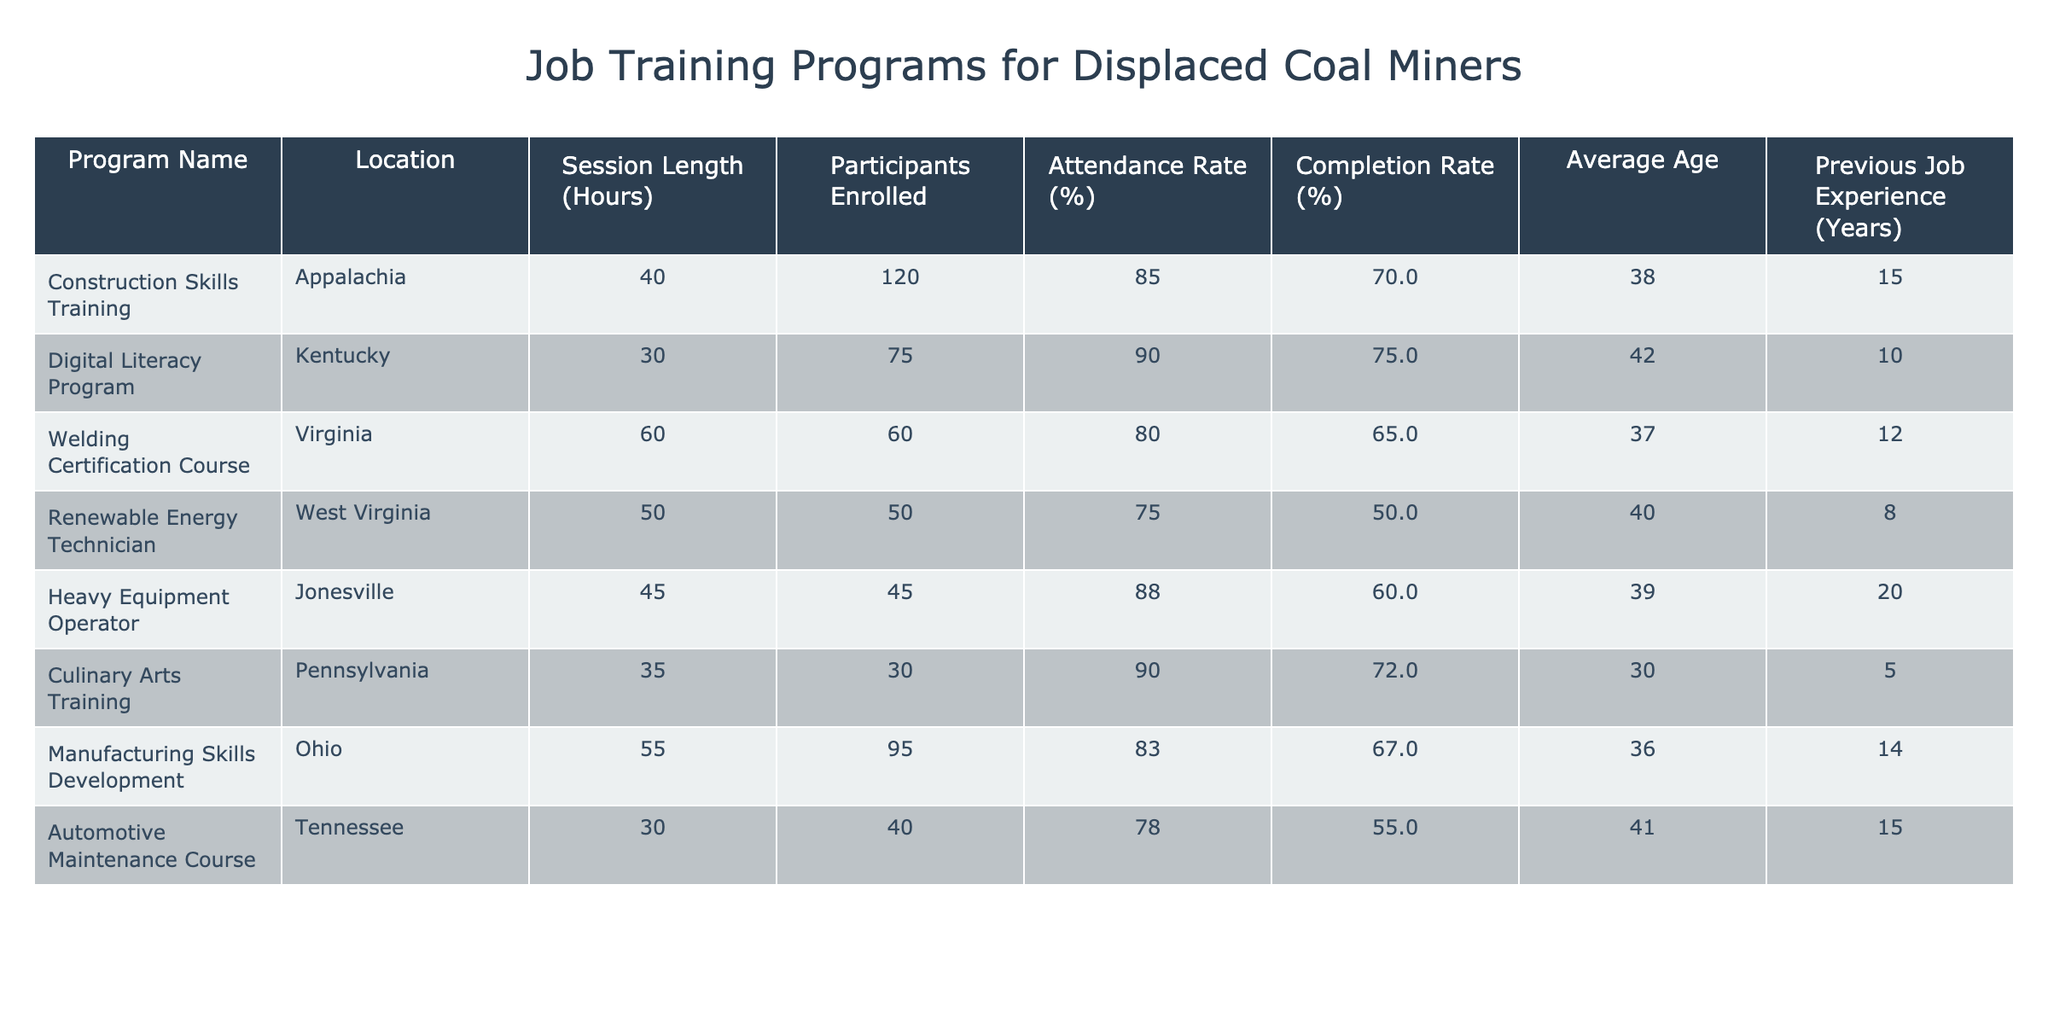What is the attendance rate for the Culinary Arts Training program? The attendance rate for the Culinary Arts Training program is listed in the table under the "Attendance Rate (%)" column for that program. It shows 90%.
Answer: 90% Which training program has the highest completion rate? By comparing the "Completion Rate (%)" for all programs, the Construction Skills Training program has the highest completion rate at 70%.
Answer: 70% What is the average session length for the training programs listed? To find the average session length, sum the session lengths of all programs (40 + 30 + 60 + 50 + 45 + 35 + 55 + 30 = 400 hours) and then divide by the number of programs (8), resulting in an average of 50 hours.
Answer: 50 hours Is the attendance rate for the Heavy Equipment Operator program greater than the completion rate for the Welding Certification Course? Check the attendance rate for the Heavy Equipment Operator program (88%) and the completion rate for the Welding Certification Course (65%). Since 88% is greater than 65%, the statement is true.
Answer: Yes What is the total number of participants enrolled across all programs? Add the number of participants from each program (120 + 75 + 60 + 50 + 45 + 30 + 95 + 40 = 515). The total number of participants enrolled across all programs is 515.
Answer: 515 Which program has the lowest attendance rate, and what is that rate? The program with the lowest attendance rate can be determined by looking at all attendance rates. The Renewable Energy Technician program has the lowest attendance rate at 75%.
Answer: 75% Are there more programs with an attendance rate of 85% or higher than those with a completion rate of 70% or higher? Count the number of programs with attendance rates of 85% or higher (Construction Skills Training, Digital Literacy Program, Heavy Equipment Operator, and Culinary Arts Training: 4 programs) and those with completion rates of 70% or higher (Construction Skills Training, Digital Literacy Program, and Culinary Arts Training: 3 programs). There are more programs with an attendance rate of 85% or higher.
Answer: Yes What is the average age of participants in the Welding Certification Course and Culinary Arts Training? Find the average of the ages listed for the Welding Certification Course (37) and the Culinary Arts Training (30). The average is calculated as (37 + 30) / 2 = 33.5.
Answer: 33.5 